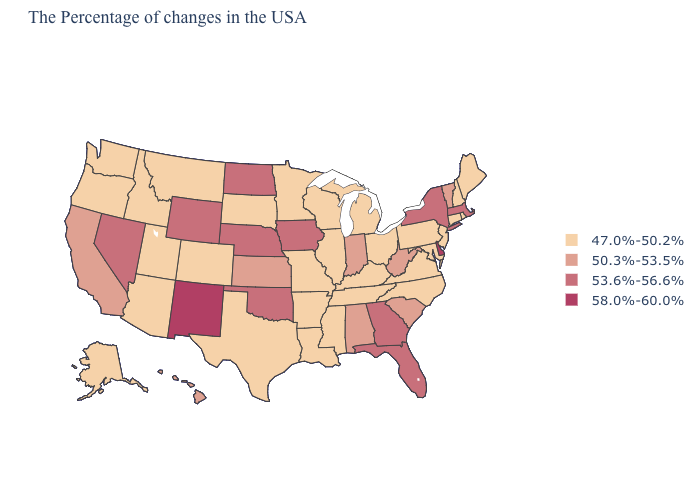What is the value of California?
Keep it brief. 50.3%-53.5%. Does Nevada have the lowest value in the West?
Quick response, please. No. Is the legend a continuous bar?
Concise answer only. No. Name the states that have a value in the range 47.0%-50.2%?
Write a very short answer. Maine, Rhode Island, New Hampshire, Connecticut, New Jersey, Maryland, Pennsylvania, Virginia, North Carolina, Ohio, Michigan, Kentucky, Tennessee, Wisconsin, Illinois, Mississippi, Louisiana, Missouri, Arkansas, Minnesota, Texas, South Dakota, Colorado, Utah, Montana, Arizona, Idaho, Washington, Oregon, Alaska. What is the value of Minnesota?
Concise answer only. 47.0%-50.2%. Which states have the lowest value in the USA?
Short answer required. Maine, Rhode Island, New Hampshire, Connecticut, New Jersey, Maryland, Pennsylvania, Virginia, North Carolina, Ohio, Michigan, Kentucky, Tennessee, Wisconsin, Illinois, Mississippi, Louisiana, Missouri, Arkansas, Minnesota, Texas, South Dakota, Colorado, Utah, Montana, Arizona, Idaho, Washington, Oregon, Alaska. Name the states that have a value in the range 53.6%-56.6%?
Give a very brief answer. Massachusetts, New York, Florida, Georgia, Iowa, Nebraska, Oklahoma, North Dakota, Wyoming, Nevada. Does the first symbol in the legend represent the smallest category?
Short answer required. Yes. Name the states that have a value in the range 58.0%-60.0%?
Concise answer only. Delaware, New Mexico. Among the states that border New York , does Massachusetts have the lowest value?
Quick response, please. No. What is the value of Illinois?
Give a very brief answer. 47.0%-50.2%. What is the lowest value in the USA?
Be succinct. 47.0%-50.2%. Name the states that have a value in the range 53.6%-56.6%?
Concise answer only. Massachusetts, New York, Florida, Georgia, Iowa, Nebraska, Oklahoma, North Dakota, Wyoming, Nevada. Name the states that have a value in the range 58.0%-60.0%?
Keep it brief. Delaware, New Mexico. 